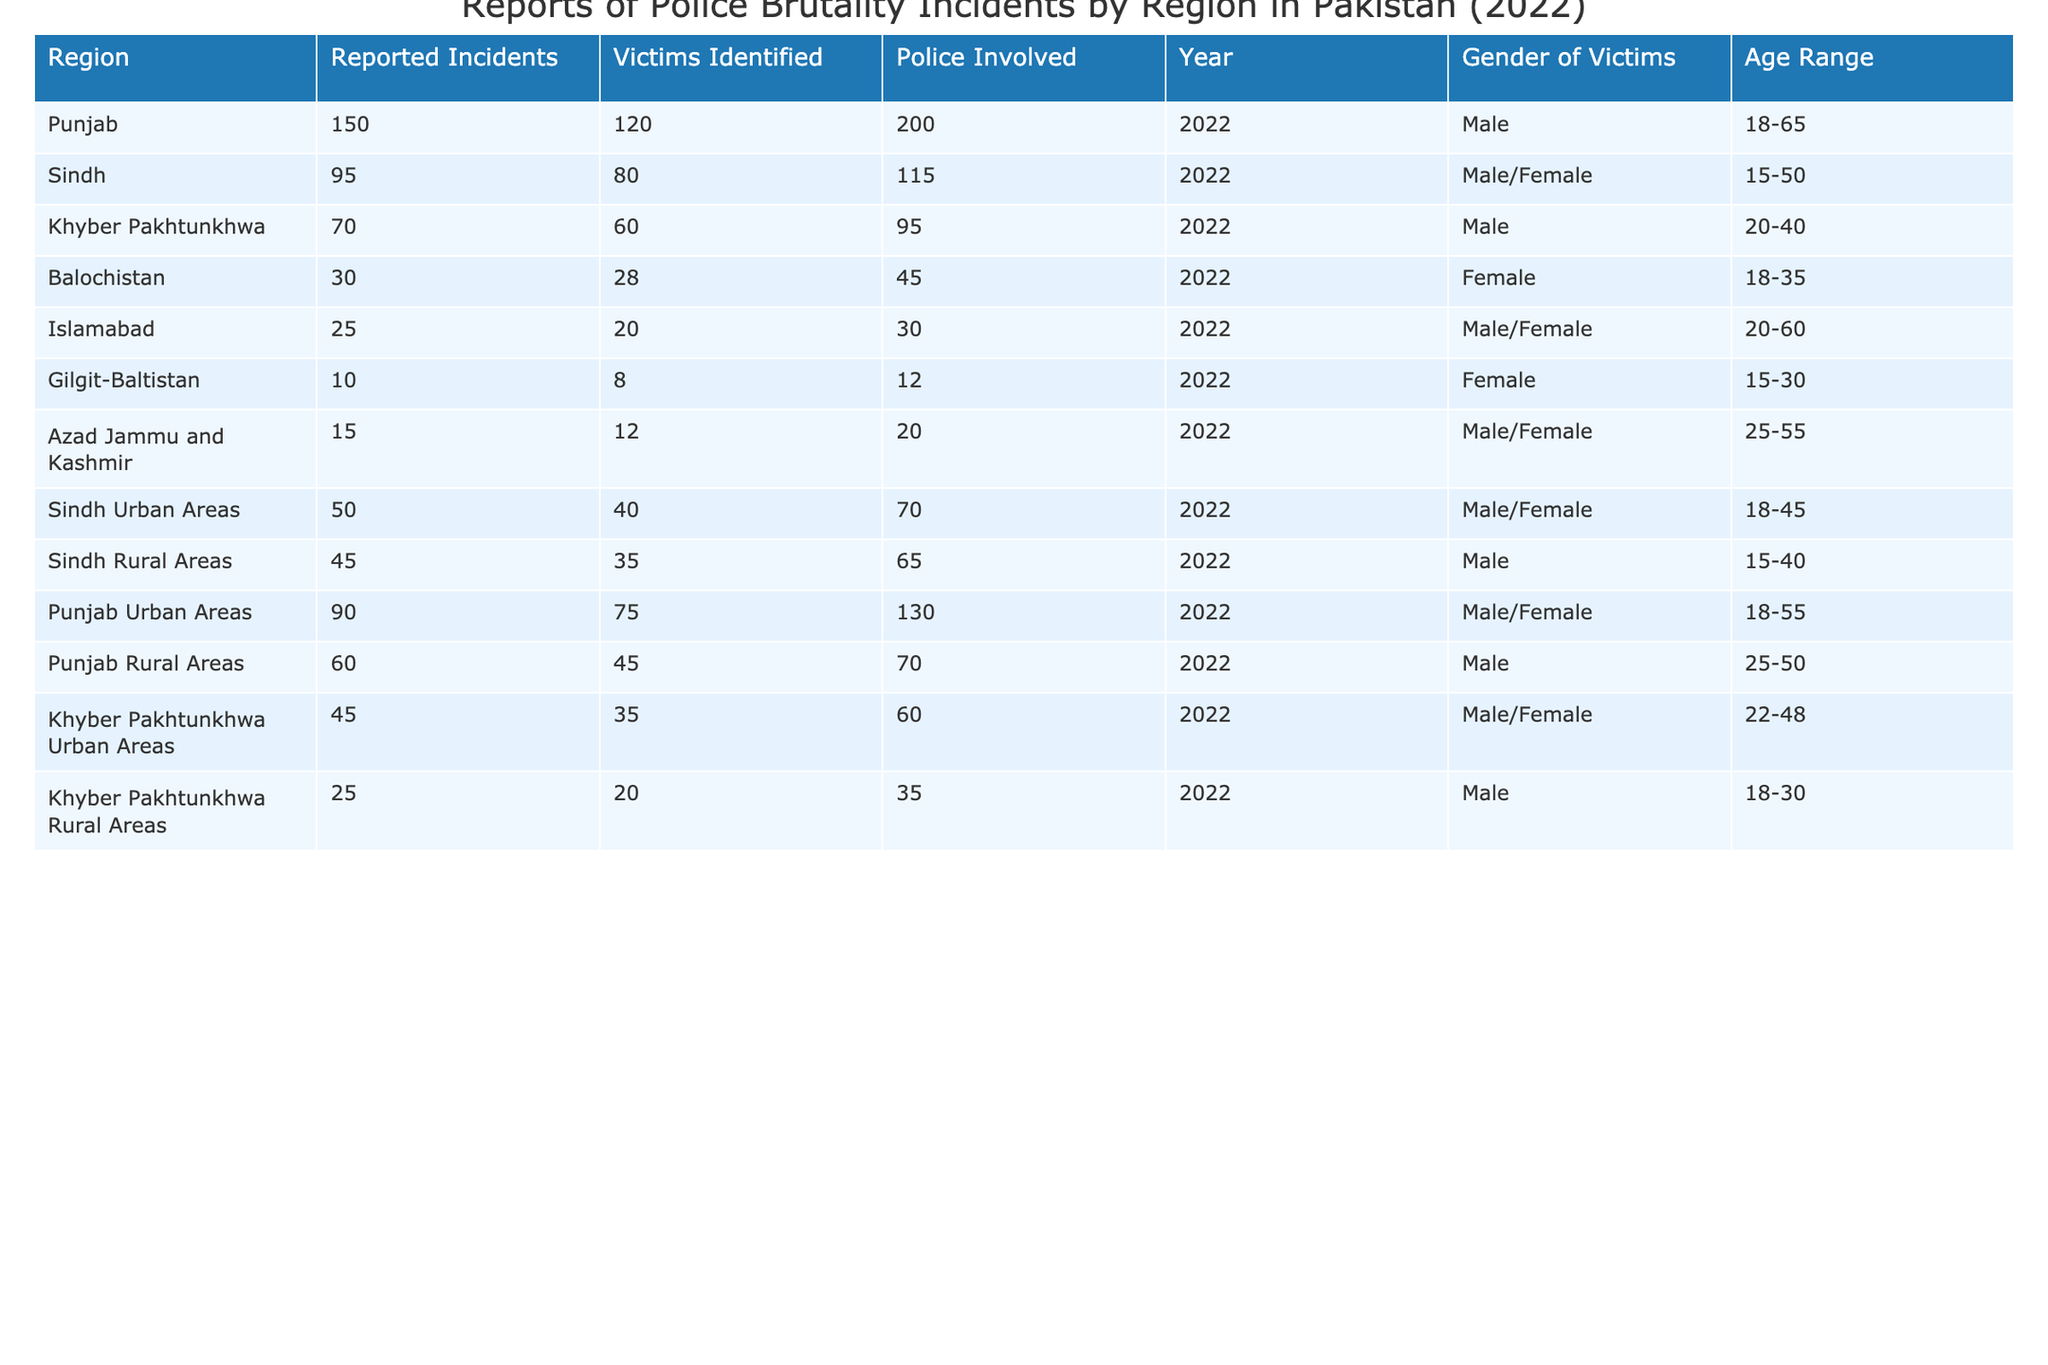What region reported the highest number of police brutality incidents? According to the table, Punjab has the highest number of reported incidents at 150.
Answer: Punjab What is the total number of victims identified across all regions? To find the total number of identified victims, we sum the values: 120 (Punjab) + 80 (Sindh) + 60 (Khyber Pakhtunkhwa) + 28 (Balochistan) + 20 (Islamabad) + 8 (Gilgit-Baltistan) + 12 (Azad Jammu and Kashmir) + 40 (Sindh Urban Areas) + 35 (Sindh Rural Areas) + 75 (Punjab Urban Areas) + 45 (Punjab Rural Areas) + 35 (Khyber Pakhtunkhwa Urban Areas) + 20 (Khyber Pakhtunkhwa Rural Areas) =  533.
Answer: 533 Which region has the lowest number of reported police brutality incidents? The region with the lowest reported incidents is Gilgit-Baltistan, with only 10 incidents reported.
Answer: Gilgit-Baltistan Is the age range of victims in Islamabad broader than in Balochistan? The age range in Islamabad is 20-60, while in Balochistan it is 18-35, so the age range in Islamabad is broader.
Answer: Yes What is the average number of police involved in the incidents for the regions listed? We calculate the average by summing the police involved across regions: 200 + 115 + 95 + 45 + 30 + 12 + 20 + 70 + 65 + 130 + 70 + 60 + 35 = 1077. There are 13 regions, so the average is 1077/13 = approximately 82.08.
Answer: 82.08 How many more incidents were reported in Punjab compared to Khyber Pakhtunkhwa? Punjab reported 150 incidents and Khyber Pakhtunkhwa reported 70; the difference is 150 - 70 = 80.
Answer: 80 Which gender is most frequently identified among victims in Balochistan? The table indicates that victims in Balochistan are primarily female, as it lists 'Female' as the gender of victims.
Answer: Female In which area do both male and female victims exist, and how many incidents were reported there? In Sindh, both male and female victims are reported, with a total of 95 incidents.
Answer: Sindh, 95 incidents What is the total number of police involved in incidents in Punjab Urban and Rural Areas combined? The number of police involved in Punjab Urban Areas is 130 and in Punjab Rural Areas is 70. Adding these gives 130 + 70 = 200.
Answer: 200 Which age range corresponds to the largest number of reported victims in Sindh Rural Areas? The age range for victims in Sindh Rural Areas is 15-40, which corresponds to 35 victims identified.
Answer: 15-40 